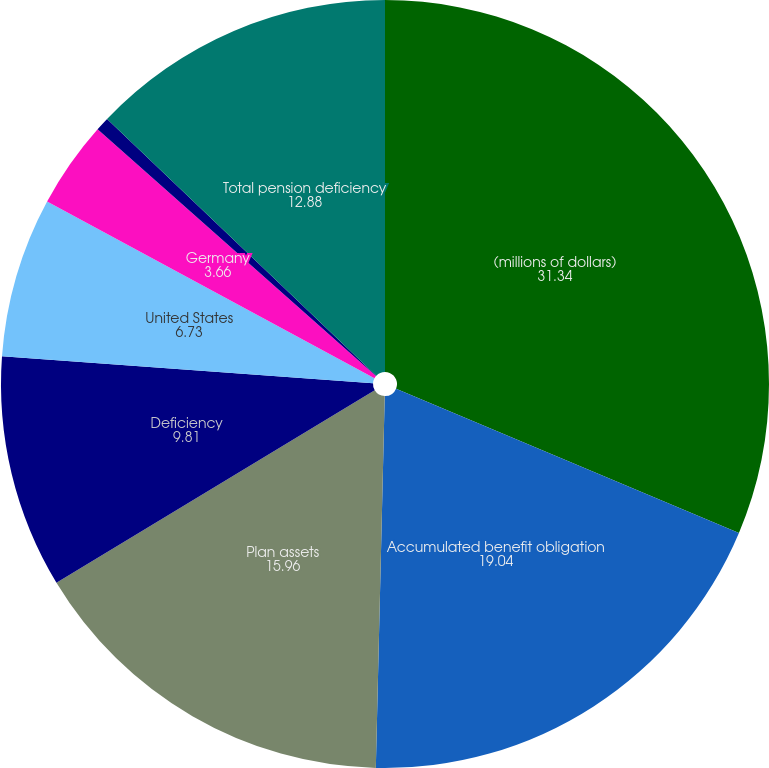Convert chart to OTSL. <chart><loc_0><loc_0><loc_500><loc_500><pie_chart><fcel>(millions of dollars)<fcel>Accumulated benefit obligation<fcel>Plan assets<fcel>Deficiency<fcel>United States<fcel>Germany<fcel>Other<fcel>Total pension deficiency<nl><fcel>31.34%<fcel>19.04%<fcel>15.96%<fcel>9.81%<fcel>6.73%<fcel>3.66%<fcel>0.58%<fcel>12.88%<nl></chart> 